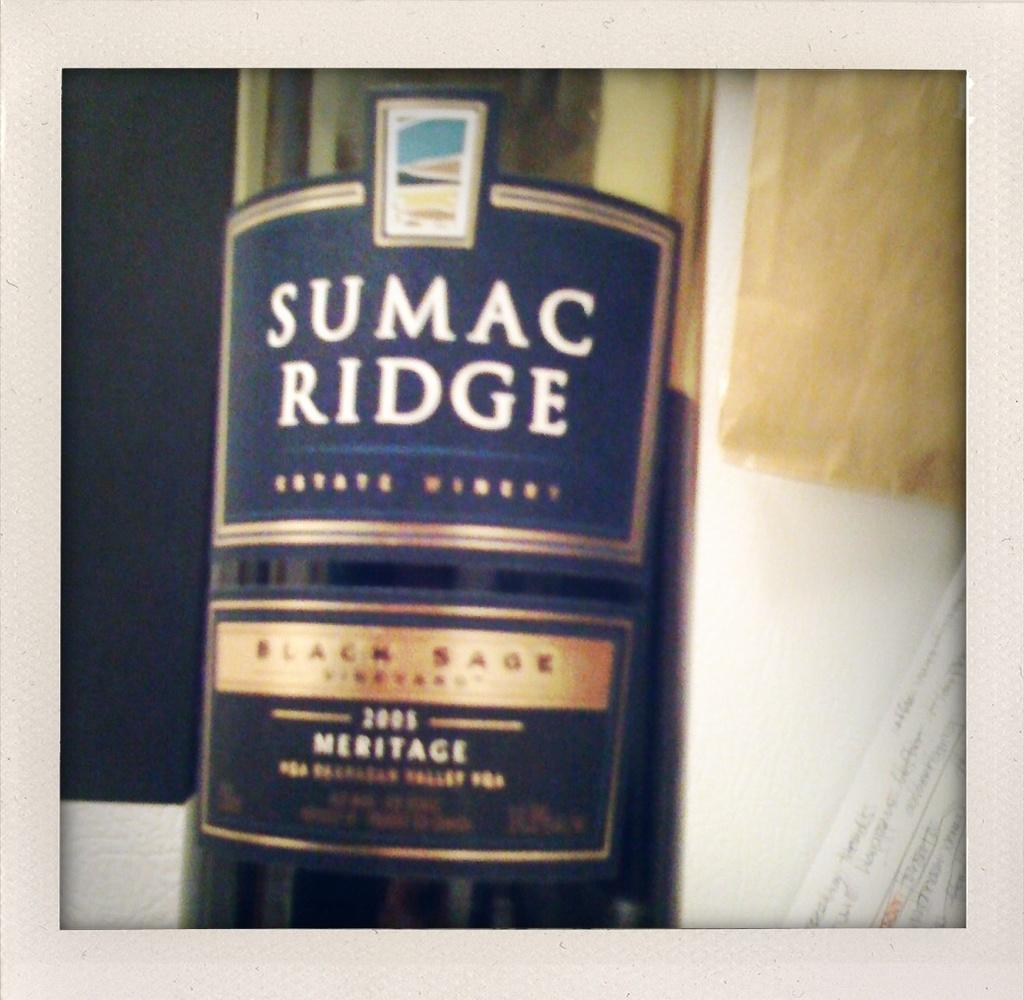Provide a one-sentence caption for the provided image. A bottle of SUMAC RIDGE sits against a blue and white background. 